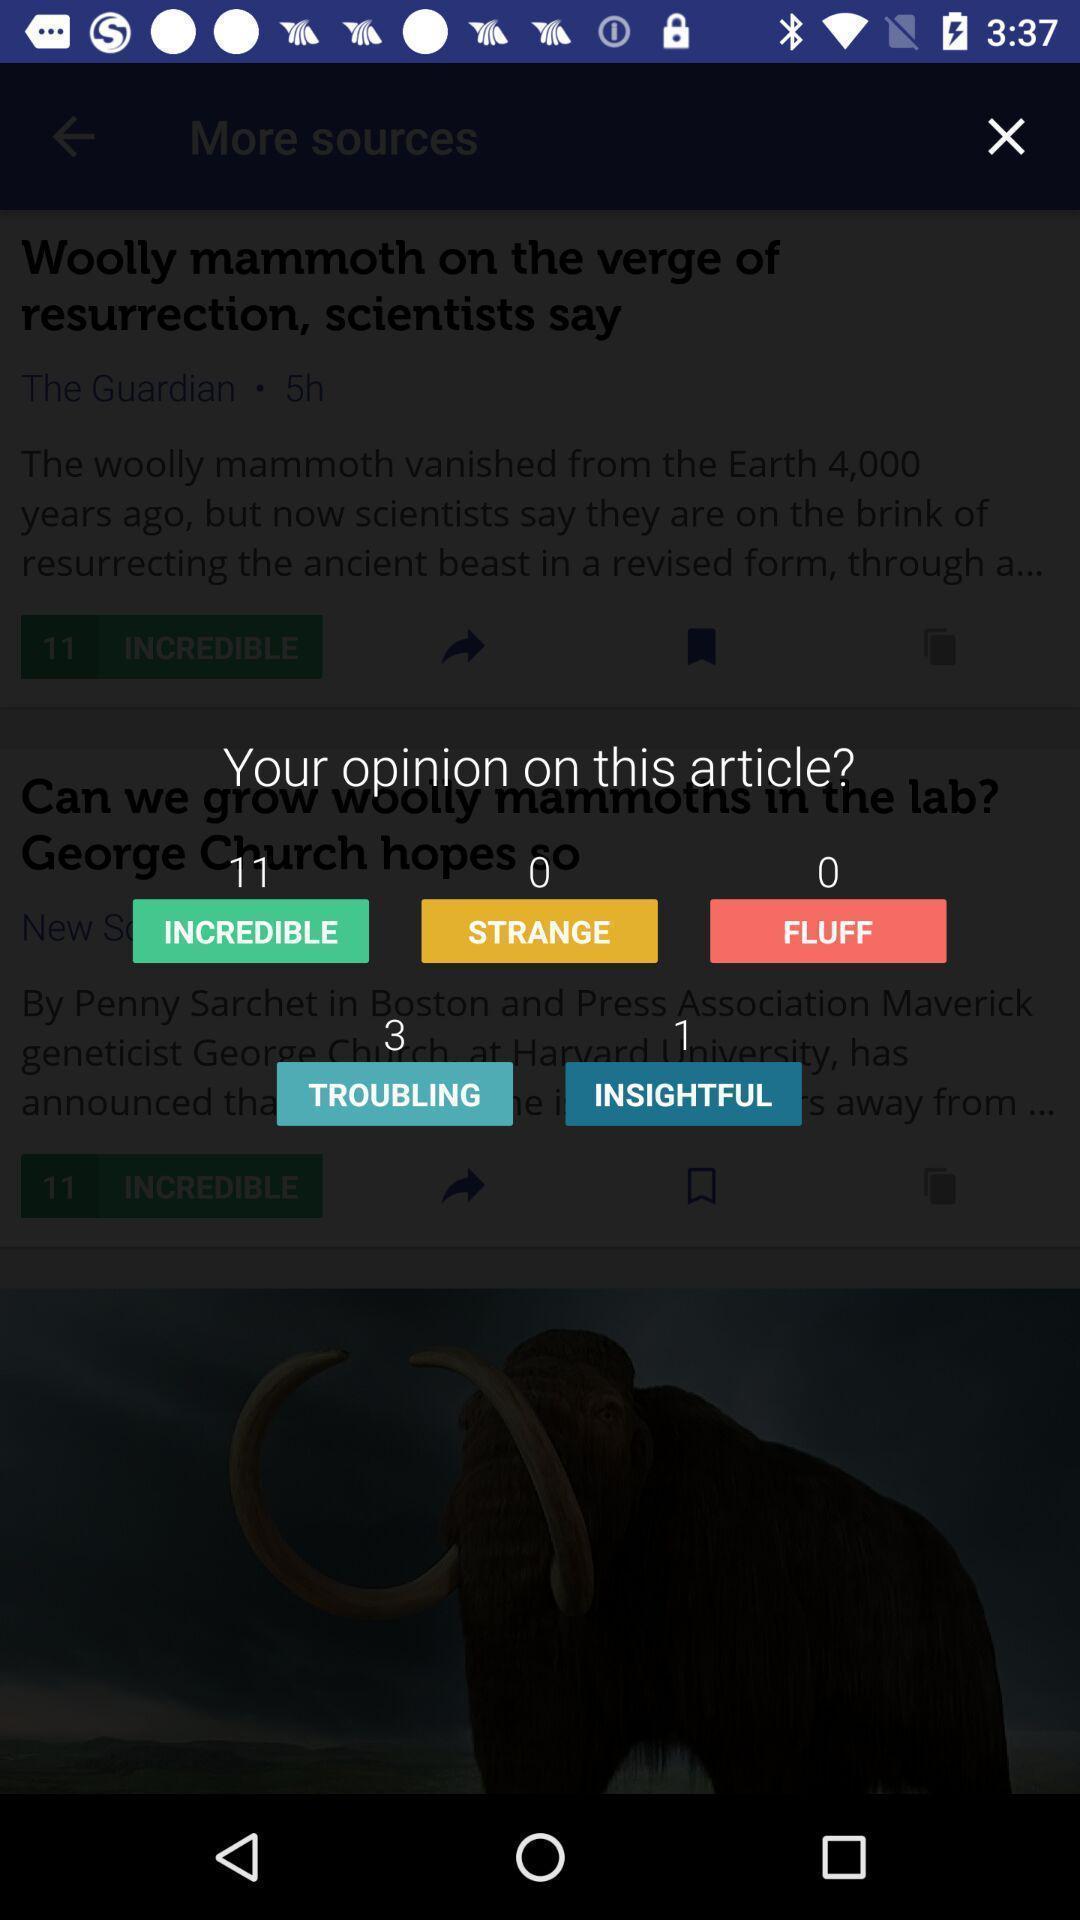What details can you identify in this image? Pop up displaying list of options. 